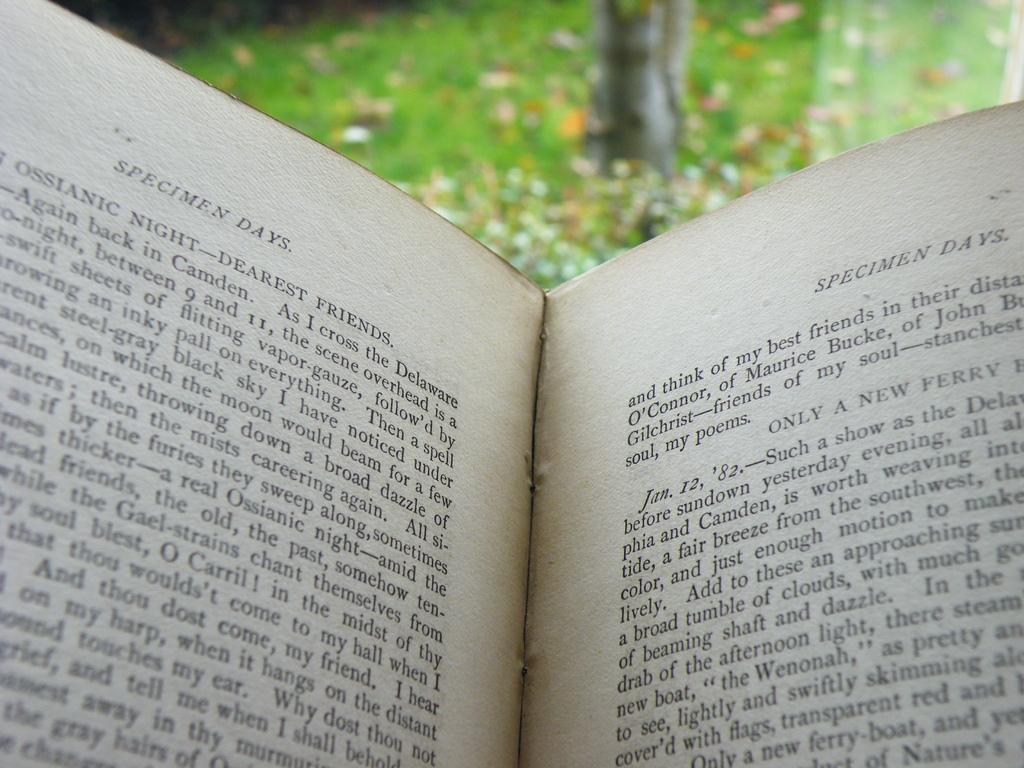<image>
Render a clear and concise summary of the photo. A book outside in the woods with Specimen Days written on it. 